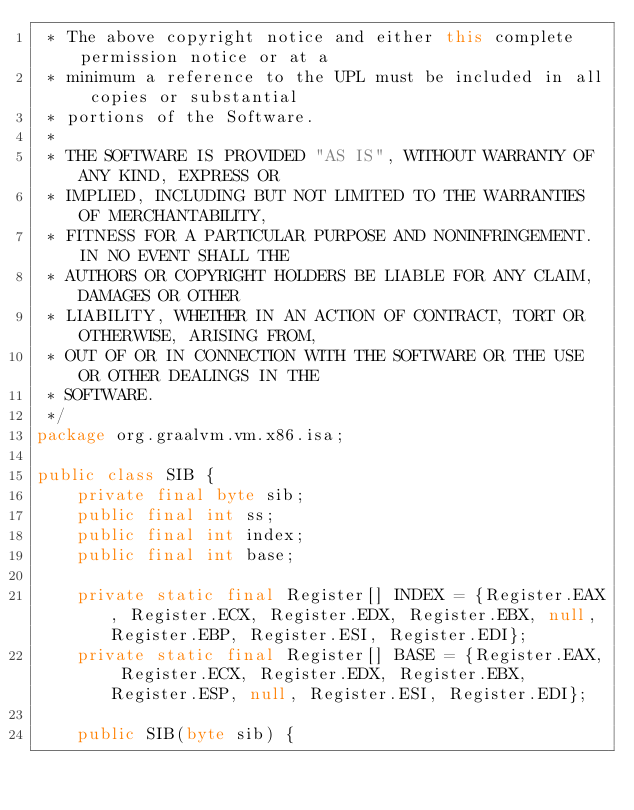Convert code to text. <code><loc_0><loc_0><loc_500><loc_500><_Java_> * The above copyright notice and either this complete permission notice or at a
 * minimum a reference to the UPL must be included in all copies or substantial
 * portions of the Software.
 *
 * THE SOFTWARE IS PROVIDED "AS IS", WITHOUT WARRANTY OF ANY KIND, EXPRESS OR
 * IMPLIED, INCLUDING BUT NOT LIMITED TO THE WARRANTIES OF MERCHANTABILITY,
 * FITNESS FOR A PARTICULAR PURPOSE AND NONINFRINGEMENT. IN NO EVENT SHALL THE
 * AUTHORS OR COPYRIGHT HOLDERS BE LIABLE FOR ANY CLAIM, DAMAGES OR OTHER
 * LIABILITY, WHETHER IN AN ACTION OF CONTRACT, TORT OR OTHERWISE, ARISING FROM,
 * OUT OF OR IN CONNECTION WITH THE SOFTWARE OR THE USE OR OTHER DEALINGS IN THE
 * SOFTWARE.
 */
package org.graalvm.vm.x86.isa;

public class SIB {
    private final byte sib;
    public final int ss;
    public final int index;
    public final int base;

    private static final Register[] INDEX = {Register.EAX, Register.ECX, Register.EDX, Register.EBX, null, Register.EBP, Register.ESI, Register.EDI};
    private static final Register[] BASE = {Register.EAX, Register.ECX, Register.EDX, Register.EBX, Register.ESP, null, Register.ESI, Register.EDI};

    public SIB(byte sib) {</code> 